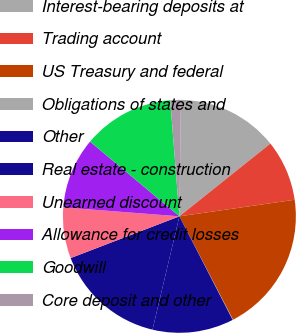Convert chart to OTSL. <chart><loc_0><loc_0><loc_500><loc_500><pie_chart><fcel>Interest-bearing deposits at<fcel>Trading account<fcel>US Treasury and federal<fcel>Obligations of states and<fcel>Other<fcel>Real estate - construction<fcel>Unearned discount<fcel>Allowance for credit losses<fcel>Goodwill<fcel>Core deposit and other<nl><fcel>14.06%<fcel>8.46%<fcel>19.66%<fcel>0.06%<fcel>11.26%<fcel>15.46%<fcel>7.06%<fcel>9.86%<fcel>12.66%<fcel>1.46%<nl></chart> 